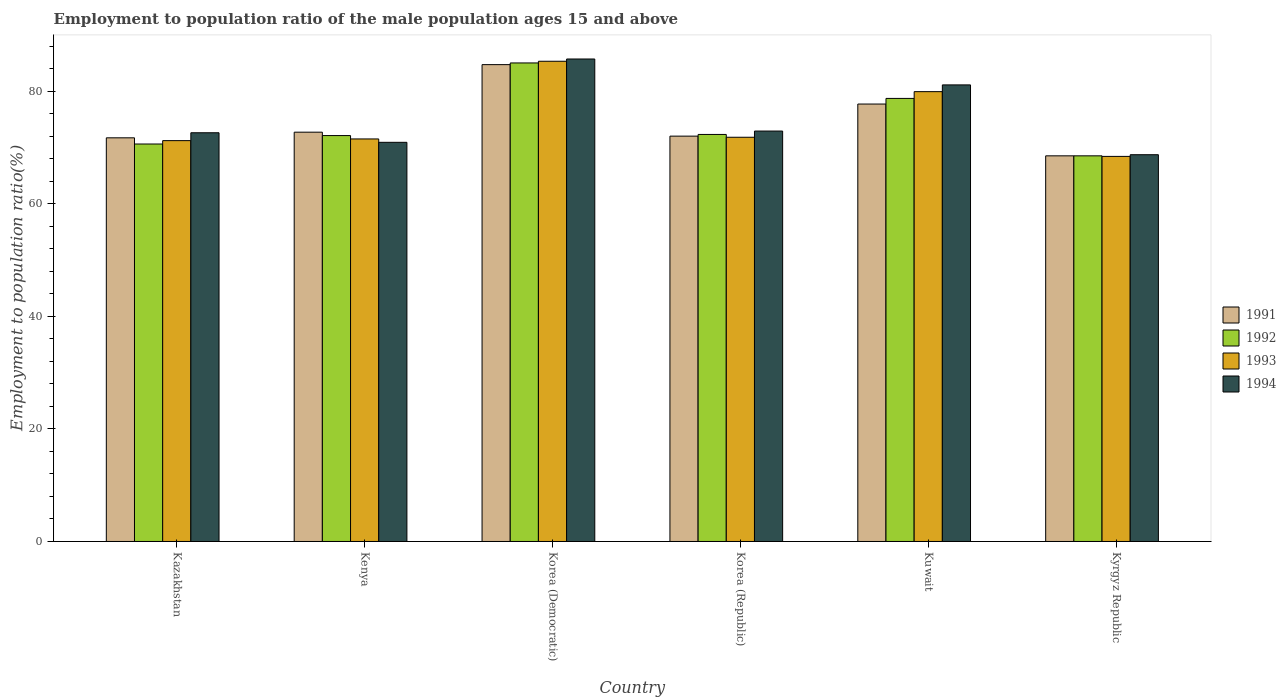Are the number of bars per tick equal to the number of legend labels?
Ensure brevity in your answer.  Yes. Are the number of bars on each tick of the X-axis equal?
Keep it short and to the point. Yes. What is the label of the 4th group of bars from the left?
Your response must be concise. Korea (Republic). What is the employment to population ratio in 1993 in Korea (Democratic)?
Offer a very short reply. 85.3. Across all countries, what is the maximum employment to population ratio in 1993?
Keep it short and to the point. 85.3. Across all countries, what is the minimum employment to population ratio in 1993?
Make the answer very short. 68.4. In which country was the employment to population ratio in 1991 maximum?
Ensure brevity in your answer.  Korea (Democratic). In which country was the employment to population ratio in 1992 minimum?
Give a very brief answer. Kyrgyz Republic. What is the total employment to population ratio in 1992 in the graph?
Your response must be concise. 447.2. What is the difference between the employment to population ratio in 1991 in Kazakhstan and that in Korea (Republic)?
Provide a succinct answer. -0.3. What is the average employment to population ratio in 1994 per country?
Make the answer very short. 75.32. What is the difference between the employment to population ratio of/in 1994 and employment to population ratio of/in 1993 in Korea (Republic)?
Ensure brevity in your answer.  1.1. What is the ratio of the employment to population ratio in 1991 in Kazakhstan to that in Korea (Republic)?
Offer a terse response. 1. Is the employment to population ratio in 1994 in Kazakhstan less than that in Kuwait?
Make the answer very short. Yes. Is the difference between the employment to population ratio in 1994 in Korea (Democratic) and Korea (Republic) greater than the difference between the employment to population ratio in 1993 in Korea (Democratic) and Korea (Republic)?
Your response must be concise. No. What is the difference between the highest and the second highest employment to population ratio in 1994?
Your answer should be compact. -8.2. What is the difference between the highest and the lowest employment to population ratio in 1993?
Your answer should be compact. 16.9. Is the sum of the employment to population ratio in 1992 in Kenya and Kuwait greater than the maximum employment to population ratio in 1991 across all countries?
Ensure brevity in your answer.  Yes. Is it the case that in every country, the sum of the employment to population ratio in 1992 and employment to population ratio in 1991 is greater than the employment to population ratio in 1994?
Your response must be concise. Yes. How many countries are there in the graph?
Your answer should be compact. 6. What is the difference between two consecutive major ticks on the Y-axis?
Offer a very short reply. 20. Are the values on the major ticks of Y-axis written in scientific E-notation?
Make the answer very short. No. Does the graph contain any zero values?
Ensure brevity in your answer.  No. Does the graph contain grids?
Provide a short and direct response. No. How are the legend labels stacked?
Provide a succinct answer. Vertical. What is the title of the graph?
Provide a succinct answer. Employment to population ratio of the male population ages 15 and above. What is the label or title of the Y-axis?
Provide a short and direct response. Employment to population ratio(%). What is the Employment to population ratio(%) in 1991 in Kazakhstan?
Give a very brief answer. 71.7. What is the Employment to population ratio(%) in 1992 in Kazakhstan?
Give a very brief answer. 70.6. What is the Employment to population ratio(%) in 1993 in Kazakhstan?
Offer a terse response. 71.2. What is the Employment to population ratio(%) in 1994 in Kazakhstan?
Your answer should be very brief. 72.6. What is the Employment to population ratio(%) of 1991 in Kenya?
Your answer should be compact. 72.7. What is the Employment to population ratio(%) of 1992 in Kenya?
Provide a succinct answer. 72.1. What is the Employment to population ratio(%) of 1993 in Kenya?
Provide a short and direct response. 71.5. What is the Employment to population ratio(%) of 1994 in Kenya?
Provide a succinct answer. 70.9. What is the Employment to population ratio(%) in 1991 in Korea (Democratic)?
Your answer should be compact. 84.7. What is the Employment to population ratio(%) in 1992 in Korea (Democratic)?
Provide a short and direct response. 85. What is the Employment to population ratio(%) of 1993 in Korea (Democratic)?
Your answer should be compact. 85.3. What is the Employment to population ratio(%) of 1994 in Korea (Democratic)?
Keep it short and to the point. 85.7. What is the Employment to population ratio(%) of 1991 in Korea (Republic)?
Give a very brief answer. 72. What is the Employment to population ratio(%) of 1992 in Korea (Republic)?
Provide a succinct answer. 72.3. What is the Employment to population ratio(%) of 1993 in Korea (Republic)?
Your response must be concise. 71.8. What is the Employment to population ratio(%) in 1994 in Korea (Republic)?
Provide a succinct answer. 72.9. What is the Employment to population ratio(%) in 1991 in Kuwait?
Your answer should be very brief. 77.7. What is the Employment to population ratio(%) of 1992 in Kuwait?
Provide a short and direct response. 78.7. What is the Employment to population ratio(%) in 1993 in Kuwait?
Ensure brevity in your answer.  79.9. What is the Employment to population ratio(%) in 1994 in Kuwait?
Make the answer very short. 81.1. What is the Employment to population ratio(%) of 1991 in Kyrgyz Republic?
Offer a very short reply. 68.5. What is the Employment to population ratio(%) in 1992 in Kyrgyz Republic?
Your response must be concise. 68.5. What is the Employment to population ratio(%) of 1993 in Kyrgyz Republic?
Provide a short and direct response. 68.4. What is the Employment to population ratio(%) in 1994 in Kyrgyz Republic?
Offer a terse response. 68.7. Across all countries, what is the maximum Employment to population ratio(%) of 1991?
Your answer should be compact. 84.7. Across all countries, what is the maximum Employment to population ratio(%) in 1993?
Provide a short and direct response. 85.3. Across all countries, what is the maximum Employment to population ratio(%) in 1994?
Make the answer very short. 85.7. Across all countries, what is the minimum Employment to population ratio(%) in 1991?
Make the answer very short. 68.5. Across all countries, what is the minimum Employment to population ratio(%) in 1992?
Offer a very short reply. 68.5. Across all countries, what is the minimum Employment to population ratio(%) of 1993?
Provide a succinct answer. 68.4. Across all countries, what is the minimum Employment to population ratio(%) of 1994?
Your response must be concise. 68.7. What is the total Employment to population ratio(%) of 1991 in the graph?
Keep it short and to the point. 447.3. What is the total Employment to population ratio(%) of 1992 in the graph?
Provide a succinct answer. 447.2. What is the total Employment to population ratio(%) of 1993 in the graph?
Keep it short and to the point. 448.1. What is the total Employment to population ratio(%) in 1994 in the graph?
Provide a succinct answer. 451.9. What is the difference between the Employment to population ratio(%) of 1991 in Kazakhstan and that in Kenya?
Provide a succinct answer. -1. What is the difference between the Employment to population ratio(%) of 1992 in Kazakhstan and that in Korea (Democratic)?
Provide a succinct answer. -14.4. What is the difference between the Employment to population ratio(%) of 1993 in Kazakhstan and that in Korea (Democratic)?
Offer a terse response. -14.1. What is the difference between the Employment to population ratio(%) in 1994 in Kazakhstan and that in Korea (Democratic)?
Ensure brevity in your answer.  -13.1. What is the difference between the Employment to population ratio(%) in 1994 in Kazakhstan and that in Korea (Republic)?
Provide a succinct answer. -0.3. What is the difference between the Employment to population ratio(%) of 1991 in Kazakhstan and that in Kuwait?
Provide a succinct answer. -6. What is the difference between the Employment to population ratio(%) of 1993 in Kazakhstan and that in Kuwait?
Make the answer very short. -8.7. What is the difference between the Employment to population ratio(%) in 1992 in Kazakhstan and that in Kyrgyz Republic?
Make the answer very short. 2.1. What is the difference between the Employment to population ratio(%) of 1994 in Kazakhstan and that in Kyrgyz Republic?
Ensure brevity in your answer.  3.9. What is the difference between the Employment to population ratio(%) in 1991 in Kenya and that in Korea (Democratic)?
Give a very brief answer. -12. What is the difference between the Employment to population ratio(%) in 1994 in Kenya and that in Korea (Democratic)?
Offer a terse response. -14.8. What is the difference between the Employment to population ratio(%) in 1991 in Kenya and that in Korea (Republic)?
Provide a succinct answer. 0.7. What is the difference between the Employment to population ratio(%) of 1992 in Kenya and that in Korea (Republic)?
Offer a terse response. -0.2. What is the difference between the Employment to population ratio(%) in 1994 in Kenya and that in Korea (Republic)?
Your answer should be very brief. -2. What is the difference between the Employment to population ratio(%) in 1993 in Kenya and that in Kuwait?
Your answer should be very brief. -8.4. What is the difference between the Employment to population ratio(%) of 1993 in Korea (Democratic) and that in Korea (Republic)?
Keep it short and to the point. 13.5. What is the difference between the Employment to population ratio(%) of 1994 in Korea (Democratic) and that in Korea (Republic)?
Your answer should be very brief. 12.8. What is the difference between the Employment to population ratio(%) of 1994 in Korea (Democratic) and that in Kuwait?
Provide a short and direct response. 4.6. What is the difference between the Employment to population ratio(%) of 1993 in Korea (Democratic) and that in Kyrgyz Republic?
Keep it short and to the point. 16.9. What is the difference between the Employment to population ratio(%) of 1991 in Korea (Republic) and that in Kuwait?
Provide a succinct answer. -5.7. What is the difference between the Employment to population ratio(%) of 1993 in Korea (Republic) and that in Kuwait?
Your response must be concise. -8.1. What is the difference between the Employment to population ratio(%) of 1991 in Korea (Republic) and that in Kyrgyz Republic?
Offer a terse response. 3.5. What is the difference between the Employment to population ratio(%) of 1993 in Korea (Republic) and that in Kyrgyz Republic?
Offer a terse response. 3.4. What is the difference between the Employment to population ratio(%) in 1991 in Kuwait and that in Kyrgyz Republic?
Your answer should be compact. 9.2. What is the difference between the Employment to population ratio(%) in 1992 in Kuwait and that in Kyrgyz Republic?
Your answer should be very brief. 10.2. What is the difference between the Employment to population ratio(%) in 1994 in Kuwait and that in Kyrgyz Republic?
Provide a short and direct response. 12.4. What is the difference between the Employment to population ratio(%) of 1991 in Kazakhstan and the Employment to population ratio(%) of 1994 in Kenya?
Offer a terse response. 0.8. What is the difference between the Employment to population ratio(%) in 1992 in Kazakhstan and the Employment to population ratio(%) in 1993 in Kenya?
Give a very brief answer. -0.9. What is the difference between the Employment to population ratio(%) of 1993 in Kazakhstan and the Employment to population ratio(%) of 1994 in Kenya?
Provide a succinct answer. 0.3. What is the difference between the Employment to population ratio(%) in 1991 in Kazakhstan and the Employment to population ratio(%) in 1992 in Korea (Democratic)?
Your answer should be very brief. -13.3. What is the difference between the Employment to population ratio(%) in 1991 in Kazakhstan and the Employment to population ratio(%) in 1993 in Korea (Democratic)?
Offer a terse response. -13.6. What is the difference between the Employment to population ratio(%) in 1991 in Kazakhstan and the Employment to population ratio(%) in 1994 in Korea (Democratic)?
Offer a very short reply. -14. What is the difference between the Employment to population ratio(%) of 1992 in Kazakhstan and the Employment to population ratio(%) of 1993 in Korea (Democratic)?
Give a very brief answer. -14.7. What is the difference between the Employment to population ratio(%) in 1992 in Kazakhstan and the Employment to population ratio(%) in 1994 in Korea (Democratic)?
Ensure brevity in your answer.  -15.1. What is the difference between the Employment to population ratio(%) in 1993 in Kazakhstan and the Employment to population ratio(%) in 1994 in Korea (Democratic)?
Offer a very short reply. -14.5. What is the difference between the Employment to population ratio(%) of 1991 in Kazakhstan and the Employment to population ratio(%) of 1993 in Korea (Republic)?
Provide a short and direct response. -0.1. What is the difference between the Employment to population ratio(%) of 1991 in Kazakhstan and the Employment to population ratio(%) of 1994 in Kuwait?
Ensure brevity in your answer.  -9.4. What is the difference between the Employment to population ratio(%) of 1992 in Kazakhstan and the Employment to population ratio(%) of 1993 in Kuwait?
Offer a terse response. -9.3. What is the difference between the Employment to population ratio(%) in 1993 in Kazakhstan and the Employment to population ratio(%) in 1994 in Kuwait?
Offer a terse response. -9.9. What is the difference between the Employment to population ratio(%) in 1991 in Kazakhstan and the Employment to population ratio(%) in 1992 in Kyrgyz Republic?
Your answer should be compact. 3.2. What is the difference between the Employment to population ratio(%) of 1991 in Kazakhstan and the Employment to population ratio(%) of 1993 in Kyrgyz Republic?
Provide a short and direct response. 3.3. What is the difference between the Employment to population ratio(%) of 1991 in Kazakhstan and the Employment to population ratio(%) of 1994 in Kyrgyz Republic?
Provide a short and direct response. 3. What is the difference between the Employment to population ratio(%) in 1992 in Kazakhstan and the Employment to population ratio(%) in 1993 in Kyrgyz Republic?
Your answer should be very brief. 2.2. What is the difference between the Employment to population ratio(%) in 1991 in Kenya and the Employment to population ratio(%) in 1993 in Korea (Democratic)?
Provide a succinct answer. -12.6. What is the difference between the Employment to population ratio(%) of 1991 in Kenya and the Employment to population ratio(%) of 1994 in Korea (Democratic)?
Your answer should be very brief. -13. What is the difference between the Employment to population ratio(%) in 1991 in Kenya and the Employment to population ratio(%) in 1992 in Korea (Republic)?
Your answer should be very brief. 0.4. What is the difference between the Employment to population ratio(%) of 1991 in Kenya and the Employment to population ratio(%) of 1994 in Korea (Republic)?
Keep it short and to the point. -0.2. What is the difference between the Employment to population ratio(%) in 1993 in Kenya and the Employment to population ratio(%) in 1994 in Kuwait?
Ensure brevity in your answer.  -9.6. What is the difference between the Employment to population ratio(%) in 1991 in Kenya and the Employment to population ratio(%) in 1992 in Kyrgyz Republic?
Offer a very short reply. 4.2. What is the difference between the Employment to population ratio(%) of 1991 in Kenya and the Employment to population ratio(%) of 1994 in Kyrgyz Republic?
Offer a very short reply. 4. What is the difference between the Employment to population ratio(%) of 1992 in Kenya and the Employment to population ratio(%) of 1993 in Kyrgyz Republic?
Provide a succinct answer. 3.7. What is the difference between the Employment to population ratio(%) of 1993 in Kenya and the Employment to population ratio(%) of 1994 in Kyrgyz Republic?
Give a very brief answer. 2.8. What is the difference between the Employment to population ratio(%) of 1991 in Korea (Democratic) and the Employment to population ratio(%) of 1992 in Korea (Republic)?
Provide a short and direct response. 12.4. What is the difference between the Employment to population ratio(%) of 1991 in Korea (Democratic) and the Employment to population ratio(%) of 1993 in Korea (Republic)?
Provide a short and direct response. 12.9. What is the difference between the Employment to population ratio(%) in 1991 in Korea (Democratic) and the Employment to population ratio(%) in 1994 in Korea (Republic)?
Ensure brevity in your answer.  11.8. What is the difference between the Employment to population ratio(%) of 1993 in Korea (Democratic) and the Employment to population ratio(%) of 1994 in Korea (Republic)?
Keep it short and to the point. 12.4. What is the difference between the Employment to population ratio(%) in 1991 in Korea (Democratic) and the Employment to population ratio(%) in 1993 in Kuwait?
Make the answer very short. 4.8. What is the difference between the Employment to population ratio(%) in 1991 in Korea (Democratic) and the Employment to population ratio(%) in 1994 in Kuwait?
Your response must be concise. 3.6. What is the difference between the Employment to population ratio(%) of 1992 in Korea (Democratic) and the Employment to population ratio(%) of 1994 in Kuwait?
Your answer should be very brief. 3.9. What is the difference between the Employment to population ratio(%) in 1993 in Korea (Democratic) and the Employment to population ratio(%) in 1994 in Kuwait?
Keep it short and to the point. 4.2. What is the difference between the Employment to population ratio(%) in 1991 in Korea (Democratic) and the Employment to population ratio(%) in 1992 in Kyrgyz Republic?
Provide a succinct answer. 16.2. What is the difference between the Employment to population ratio(%) of 1991 in Korea (Democratic) and the Employment to population ratio(%) of 1993 in Kyrgyz Republic?
Offer a terse response. 16.3. What is the difference between the Employment to population ratio(%) in 1992 in Korea (Democratic) and the Employment to population ratio(%) in 1993 in Kyrgyz Republic?
Keep it short and to the point. 16.6. What is the difference between the Employment to population ratio(%) in 1992 in Korea (Democratic) and the Employment to population ratio(%) in 1994 in Kyrgyz Republic?
Provide a succinct answer. 16.3. What is the difference between the Employment to population ratio(%) in 1991 in Korea (Republic) and the Employment to population ratio(%) in 1992 in Kuwait?
Provide a succinct answer. -6.7. What is the difference between the Employment to population ratio(%) of 1991 in Korea (Republic) and the Employment to population ratio(%) of 1993 in Kuwait?
Your answer should be very brief. -7.9. What is the difference between the Employment to population ratio(%) of 1991 in Korea (Republic) and the Employment to population ratio(%) of 1994 in Kuwait?
Your response must be concise. -9.1. What is the difference between the Employment to population ratio(%) in 1992 in Korea (Republic) and the Employment to population ratio(%) in 1993 in Kuwait?
Your answer should be very brief. -7.6. What is the difference between the Employment to population ratio(%) of 1993 in Korea (Republic) and the Employment to population ratio(%) of 1994 in Kuwait?
Your response must be concise. -9.3. What is the difference between the Employment to population ratio(%) of 1992 in Korea (Republic) and the Employment to population ratio(%) of 1993 in Kyrgyz Republic?
Provide a short and direct response. 3.9. What is the difference between the Employment to population ratio(%) of 1992 in Korea (Republic) and the Employment to population ratio(%) of 1994 in Kyrgyz Republic?
Your answer should be very brief. 3.6. What is the difference between the Employment to population ratio(%) of 1991 in Kuwait and the Employment to population ratio(%) of 1992 in Kyrgyz Republic?
Your answer should be very brief. 9.2. What is the difference between the Employment to population ratio(%) in 1991 in Kuwait and the Employment to population ratio(%) in 1994 in Kyrgyz Republic?
Keep it short and to the point. 9. What is the difference between the Employment to population ratio(%) in 1992 in Kuwait and the Employment to population ratio(%) in 1993 in Kyrgyz Republic?
Make the answer very short. 10.3. What is the difference between the Employment to population ratio(%) in 1992 in Kuwait and the Employment to population ratio(%) in 1994 in Kyrgyz Republic?
Ensure brevity in your answer.  10. What is the difference between the Employment to population ratio(%) in 1993 in Kuwait and the Employment to population ratio(%) in 1994 in Kyrgyz Republic?
Offer a terse response. 11.2. What is the average Employment to population ratio(%) in 1991 per country?
Your answer should be compact. 74.55. What is the average Employment to population ratio(%) of 1992 per country?
Keep it short and to the point. 74.53. What is the average Employment to population ratio(%) in 1993 per country?
Provide a short and direct response. 74.68. What is the average Employment to population ratio(%) in 1994 per country?
Make the answer very short. 75.32. What is the difference between the Employment to population ratio(%) of 1991 and Employment to population ratio(%) of 1992 in Kazakhstan?
Your response must be concise. 1.1. What is the difference between the Employment to population ratio(%) in 1991 and Employment to population ratio(%) in 1994 in Kazakhstan?
Provide a succinct answer. -0.9. What is the difference between the Employment to population ratio(%) of 1992 and Employment to population ratio(%) of 1994 in Kazakhstan?
Give a very brief answer. -2. What is the difference between the Employment to population ratio(%) of 1993 and Employment to population ratio(%) of 1994 in Kazakhstan?
Provide a succinct answer. -1.4. What is the difference between the Employment to population ratio(%) of 1992 and Employment to population ratio(%) of 1993 in Kenya?
Provide a succinct answer. 0.6. What is the difference between the Employment to population ratio(%) in 1992 and Employment to population ratio(%) in 1994 in Kenya?
Keep it short and to the point. 1.2. What is the difference between the Employment to population ratio(%) in 1991 and Employment to population ratio(%) in 1993 in Korea (Democratic)?
Ensure brevity in your answer.  -0.6. What is the difference between the Employment to population ratio(%) in 1992 and Employment to population ratio(%) in 1993 in Korea (Democratic)?
Keep it short and to the point. -0.3. What is the difference between the Employment to population ratio(%) in 1993 and Employment to population ratio(%) in 1994 in Korea (Democratic)?
Provide a succinct answer. -0.4. What is the difference between the Employment to population ratio(%) in 1991 and Employment to population ratio(%) in 1992 in Korea (Republic)?
Your answer should be compact. -0.3. What is the difference between the Employment to population ratio(%) of 1991 and Employment to population ratio(%) of 1993 in Korea (Republic)?
Your answer should be very brief. 0.2. What is the difference between the Employment to population ratio(%) in 1991 and Employment to population ratio(%) in 1994 in Kuwait?
Give a very brief answer. -3.4. What is the difference between the Employment to population ratio(%) of 1992 and Employment to population ratio(%) of 1993 in Kuwait?
Give a very brief answer. -1.2. What is the difference between the Employment to population ratio(%) in 1992 and Employment to population ratio(%) in 1994 in Kuwait?
Ensure brevity in your answer.  -2.4. What is the difference between the Employment to population ratio(%) of 1991 and Employment to population ratio(%) of 1992 in Kyrgyz Republic?
Your answer should be very brief. 0. What is the difference between the Employment to population ratio(%) in 1991 and Employment to population ratio(%) in 1993 in Kyrgyz Republic?
Your answer should be very brief. 0.1. What is the difference between the Employment to population ratio(%) of 1991 and Employment to population ratio(%) of 1994 in Kyrgyz Republic?
Provide a succinct answer. -0.2. What is the difference between the Employment to population ratio(%) of 1992 and Employment to population ratio(%) of 1993 in Kyrgyz Republic?
Ensure brevity in your answer.  0.1. What is the difference between the Employment to population ratio(%) in 1992 and Employment to population ratio(%) in 1994 in Kyrgyz Republic?
Give a very brief answer. -0.2. What is the difference between the Employment to population ratio(%) in 1993 and Employment to population ratio(%) in 1994 in Kyrgyz Republic?
Ensure brevity in your answer.  -0.3. What is the ratio of the Employment to population ratio(%) of 1991 in Kazakhstan to that in Kenya?
Offer a very short reply. 0.99. What is the ratio of the Employment to population ratio(%) of 1992 in Kazakhstan to that in Kenya?
Offer a very short reply. 0.98. What is the ratio of the Employment to population ratio(%) in 1993 in Kazakhstan to that in Kenya?
Give a very brief answer. 1. What is the ratio of the Employment to population ratio(%) in 1994 in Kazakhstan to that in Kenya?
Your answer should be very brief. 1.02. What is the ratio of the Employment to population ratio(%) in 1991 in Kazakhstan to that in Korea (Democratic)?
Provide a succinct answer. 0.85. What is the ratio of the Employment to population ratio(%) of 1992 in Kazakhstan to that in Korea (Democratic)?
Offer a very short reply. 0.83. What is the ratio of the Employment to population ratio(%) of 1993 in Kazakhstan to that in Korea (Democratic)?
Offer a terse response. 0.83. What is the ratio of the Employment to population ratio(%) in 1994 in Kazakhstan to that in Korea (Democratic)?
Your answer should be very brief. 0.85. What is the ratio of the Employment to population ratio(%) of 1992 in Kazakhstan to that in Korea (Republic)?
Keep it short and to the point. 0.98. What is the ratio of the Employment to population ratio(%) of 1993 in Kazakhstan to that in Korea (Republic)?
Offer a very short reply. 0.99. What is the ratio of the Employment to population ratio(%) of 1991 in Kazakhstan to that in Kuwait?
Give a very brief answer. 0.92. What is the ratio of the Employment to population ratio(%) of 1992 in Kazakhstan to that in Kuwait?
Ensure brevity in your answer.  0.9. What is the ratio of the Employment to population ratio(%) in 1993 in Kazakhstan to that in Kuwait?
Your response must be concise. 0.89. What is the ratio of the Employment to population ratio(%) in 1994 in Kazakhstan to that in Kuwait?
Give a very brief answer. 0.9. What is the ratio of the Employment to population ratio(%) of 1991 in Kazakhstan to that in Kyrgyz Republic?
Provide a succinct answer. 1.05. What is the ratio of the Employment to population ratio(%) in 1992 in Kazakhstan to that in Kyrgyz Republic?
Provide a succinct answer. 1.03. What is the ratio of the Employment to population ratio(%) of 1993 in Kazakhstan to that in Kyrgyz Republic?
Your response must be concise. 1.04. What is the ratio of the Employment to population ratio(%) of 1994 in Kazakhstan to that in Kyrgyz Republic?
Ensure brevity in your answer.  1.06. What is the ratio of the Employment to population ratio(%) in 1991 in Kenya to that in Korea (Democratic)?
Your answer should be compact. 0.86. What is the ratio of the Employment to population ratio(%) in 1992 in Kenya to that in Korea (Democratic)?
Your answer should be very brief. 0.85. What is the ratio of the Employment to population ratio(%) in 1993 in Kenya to that in Korea (Democratic)?
Give a very brief answer. 0.84. What is the ratio of the Employment to population ratio(%) in 1994 in Kenya to that in Korea (Democratic)?
Keep it short and to the point. 0.83. What is the ratio of the Employment to population ratio(%) of 1991 in Kenya to that in Korea (Republic)?
Your answer should be very brief. 1.01. What is the ratio of the Employment to population ratio(%) in 1993 in Kenya to that in Korea (Republic)?
Offer a terse response. 1. What is the ratio of the Employment to population ratio(%) in 1994 in Kenya to that in Korea (Republic)?
Provide a succinct answer. 0.97. What is the ratio of the Employment to population ratio(%) in 1991 in Kenya to that in Kuwait?
Give a very brief answer. 0.94. What is the ratio of the Employment to population ratio(%) of 1992 in Kenya to that in Kuwait?
Keep it short and to the point. 0.92. What is the ratio of the Employment to population ratio(%) of 1993 in Kenya to that in Kuwait?
Your answer should be very brief. 0.89. What is the ratio of the Employment to population ratio(%) of 1994 in Kenya to that in Kuwait?
Make the answer very short. 0.87. What is the ratio of the Employment to population ratio(%) in 1991 in Kenya to that in Kyrgyz Republic?
Ensure brevity in your answer.  1.06. What is the ratio of the Employment to population ratio(%) of 1992 in Kenya to that in Kyrgyz Republic?
Offer a terse response. 1.05. What is the ratio of the Employment to population ratio(%) of 1993 in Kenya to that in Kyrgyz Republic?
Your answer should be compact. 1.05. What is the ratio of the Employment to population ratio(%) of 1994 in Kenya to that in Kyrgyz Republic?
Ensure brevity in your answer.  1.03. What is the ratio of the Employment to population ratio(%) of 1991 in Korea (Democratic) to that in Korea (Republic)?
Offer a terse response. 1.18. What is the ratio of the Employment to population ratio(%) of 1992 in Korea (Democratic) to that in Korea (Republic)?
Keep it short and to the point. 1.18. What is the ratio of the Employment to population ratio(%) in 1993 in Korea (Democratic) to that in Korea (Republic)?
Offer a very short reply. 1.19. What is the ratio of the Employment to population ratio(%) in 1994 in Korea (Democratic) to that in Korea (Republic)?
Make the answer very short. 1.18. What is the ratio of the Employment to population ratio(%) in 1991 in Korea (Democratic) to that in Kuwait?
Provide a short and direct response. 1.09. What is the ratio of the Employment to population ratio(%) in 1992 in Korea (Democratic) to that in Kuwait?
Offer a very short reply. 1.08. What is the ratio of the Employment to population ratio(%) in 1993 in Korea (Democratic) to that in Kuwait?
Your answer should be compact. 1.07. What is the ratio of the Employment to population ratio(%) in 1994 in Korea (Democratic) to that in Kuwait?
Ensure brevity in your answer.  1.06. What is the ratio of the Employment to population ratio(%) in 1991 in Korea (Democratic) to that in Kyrgyz Republic?
Provide a succinct answer. 1.24. What is the ratio of the Employment to population ratio(%) in 1992 in Korea (Democratic) to that in Kyrgyz Republic?
Provide a short and direct response. 1.24. What is the ratio of the Employment to population ratio(%) in 1993 in Korea (Democratic) to that in Kyrgyz Republic?
Your answer should be very brief. 1.25. What is the ratio of the Employment to population ratio(%) of 1994 in Korea (Democratic) to that in Kyrgyz Republic?
Your answer should be compact. 1.25. What is the ratio of the Employment to population ratio(%) in 1991 in Korea (Republic) to that in Kuwait?
Your answer should be compact. 0.93. What is the ratio of the Employment to population ratio(%) in 1992 in Korea (Republic) to that in Kuwait?
Your response must be concise. 0.92. What is the ratio of the Employment to population ratio(%) of 1993 in Korea (Republic) to that in Kuwait?
Your response must be concise. 0.9. What is the ratio of the Employment to population ratio(%) of 1994 in Korea (Republic) to that in Kuwait?
Offer a terse response. 0.9. What is the ratio of the Employment to population ratio(%) of 1991 in Korea (Republic) to that in Kyrgyz Republic?
Provide a short and direct response. 1.05. What is the ratio of the Employment to population ratio(%) of 1992 in Korea (Republic) to that in Kyrgyz Republic?
Your answer should be compact. 1.06. What is the ratio of the Employment to population ratio(%) in 1993 in Korea (Republic) to that in Kyrgyz Republic?
Your answer should be compact. 1.05. What is the ratio of the Employment to population ratio(%) in 1994 in Korea (Republic) to that in Kyrgyz Republic?
Ensure brevity in your answer.  1.06. What is the ratio of the Employment to population ratio(%) in 1991 in Kuwait to that in Kyrgyz Republic?
Keep it short and to the point. 1.13. What is the ratio of the Employment to population ratio(%) of 1992 in Kuwait to that in Kyrgyz Republic?
Make the answer very short. 1.15. What is the ratio of the Employment to population ratio(%) in 1993 in Kuwait to that in Kyrgyz Republic?
Offer a terse response. 1.17. What is the ratio of the Employment to population ratio(%) of 1994 in Kuwait to that in Kyrgyz Republic?
Your answer should be very brief. 1.18. What is the difference between the highest and the second highest Employment to population ratio(%) of 1992?
Offer a very short reply. 6.3. What is the difference between the highest and the second highest Employment to population ratio(%) of 1993?
Your answer should be compact. 5.4. What is the difference between the highest and the lowest Employment to population ratio(%) in 1991?
Keep it short and to the point. 16.2. What is the difference between the highest and the lowest Employment to population ratio(%) in 1993?
Your response must be concise. 16.9. 